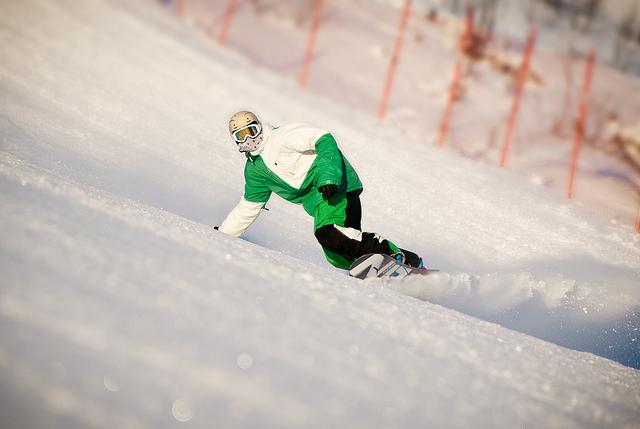What color is his right sleeve?
Write a very short answer. White. Is he wearing a helmet?
Give a very brief answer. Yes. What is the orange fence for?
Concise answer only. Safety. What does the snowboarder use to protect their face in this photo?
Give a very brief answer. Goggles. 